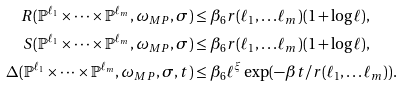Convert formula to latex. <formula><loc_0><loc_0><loc_500><loc_500>R ( \mathbb { P } ^ { \ell _ { 1 } } \times \dots \times \mathbb { P } ^ { \ell _ { m } } , \omega _ { M P } , \sigma ) & \leq \beta _ { 6 } r ( \ell _ { 1 } , \dots \ell _ { m } ) ( 1 + \log \ell ) , \\ S ( \mathbb { P } ^ { \ell _ { 1 } } \times \dots \times \mathbb { P } ^ { \ell _ { m } } , \omega _ { M P } , \sigma ) & \leq \beta _ { 6 } r ( \ell _ { 1 } , \dots \ell _ { m } ) ( 1 + \log \ell ) , \\ \Delta ( \mathbb { P } ^ { \ell _ { 1 } } \times \dots \times \mathbb { P } ^ { \ell _ { m } } , \omega _ { M P } , \sigma , t ) & \leq \beta _ { 6 } \ell ^ { \xi } \exp ( - \beta t / r ( \ell _ { 1 } , \dots \ell _ { m } ) ) . \\</formula> 